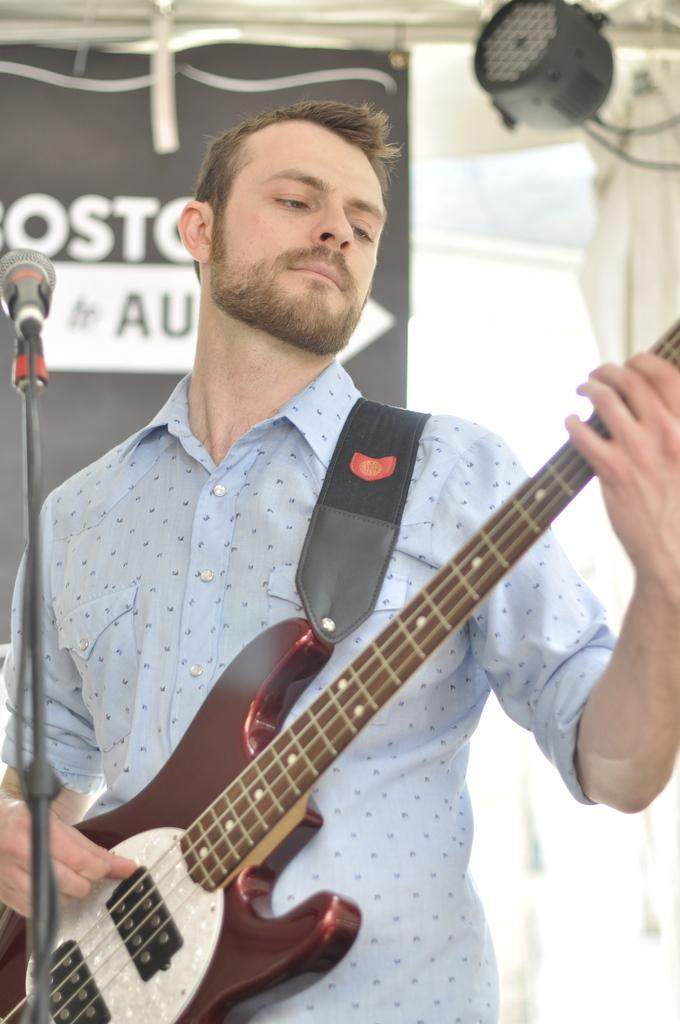Who is the main subject in the image? There is a man in the image. What is the man holding in the image? The man is holding a guitar. What object is in front of the man? There is a microphone in front of the man. What can be seen in the background of the image? There are curtains and lighting visible in the background of the image. What type of insect is crawling on the man's guitar in the image? There are no insects present in the image; the man is holding a guitar without any insects on it. 